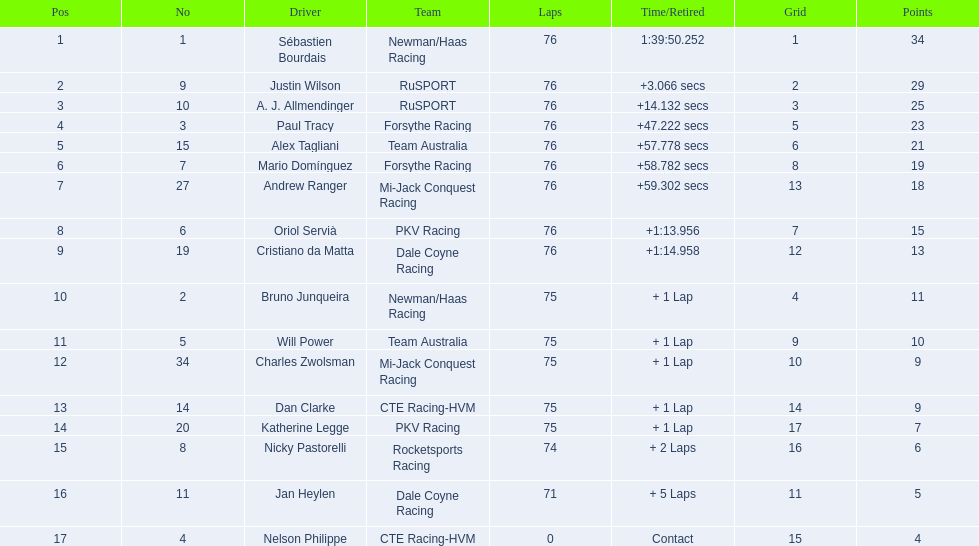What was alex taglini's concluding score in the tecate grand prix? 21. What was paul tracy's concluding score in the tecate grand prix? 23. Which racer ended up in the first place? Paul Tracy. 